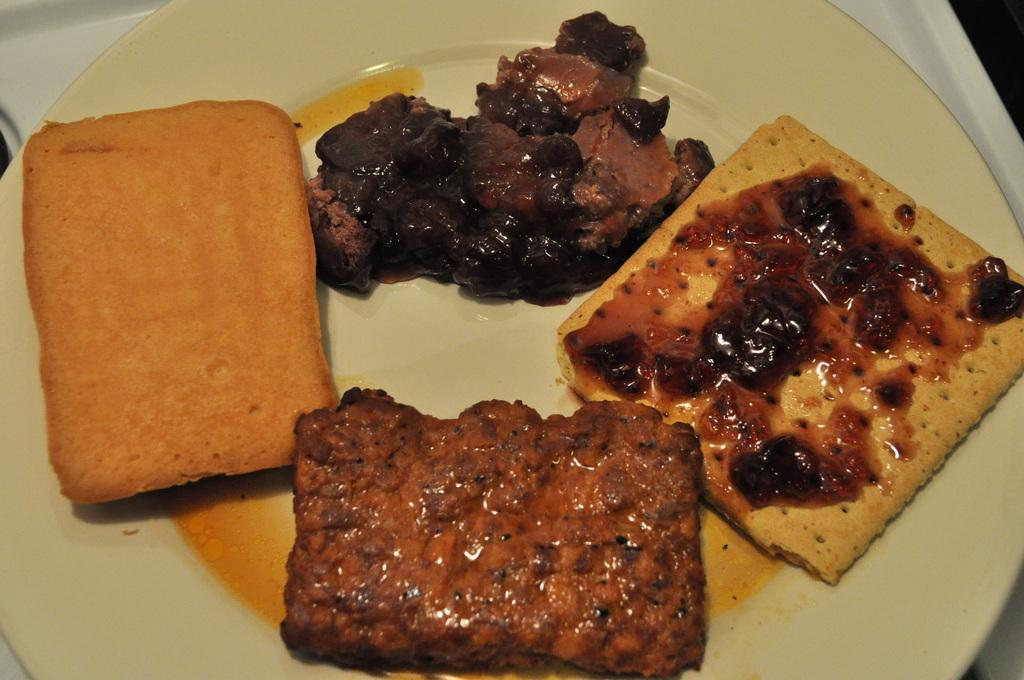What is present on the tray in the image? There is a plate on the tray in the image. What is on the plate? There is food on the plate. What type of lamp is illuminating the food on the plate? There is no lamp present in the image; the food on the plate is not being illuminated by a lamp. 